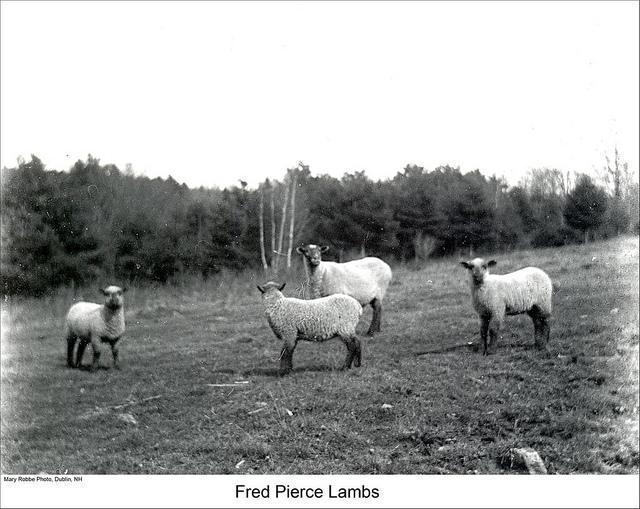How many sheep are there?
Give a very brief answer. 4. How many sheep can be seen?
Give a very brief answer. 4. 